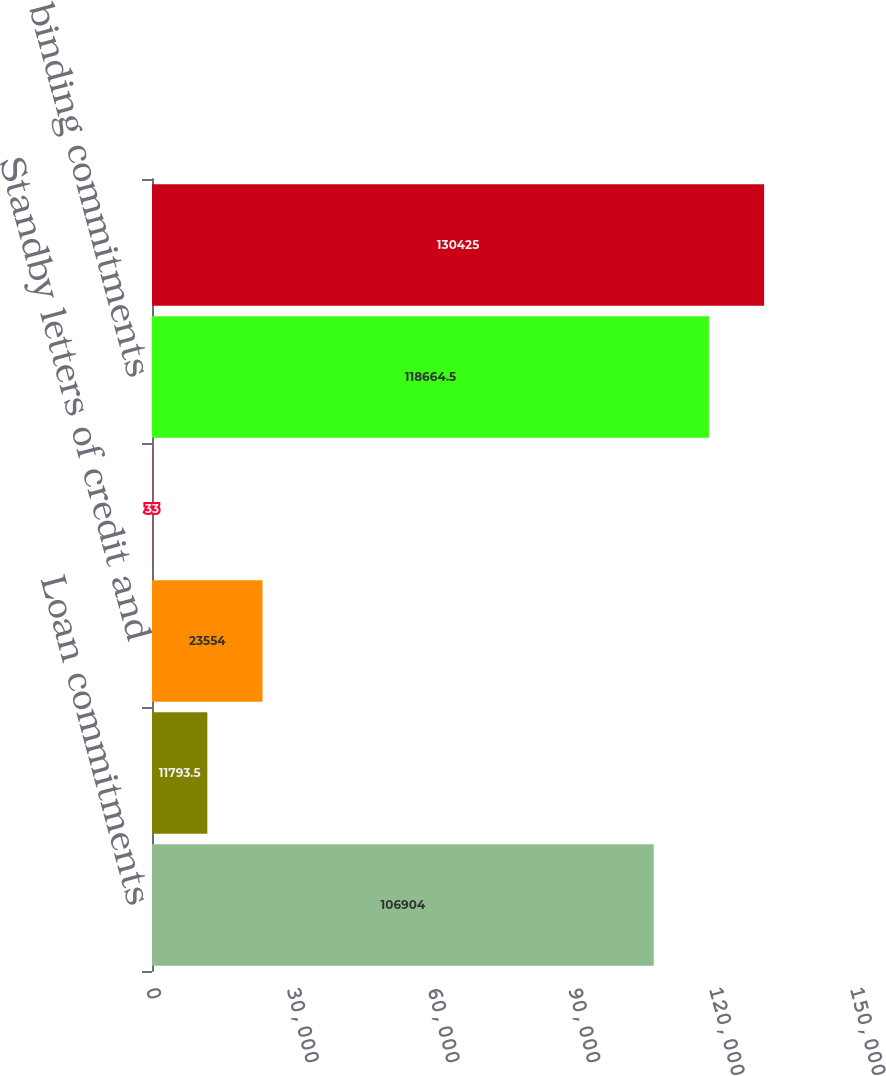<chart> <loc_0><loc_0><loc_500><loc_500><bar_chart><fcel>Loan commitments<fcel>Home equity lines of credit<fcel>Standby letters of credit and<fcel>Commercial letters of credit<fcel>Legally binding commitments<fcel>Total credit extension<nl><fcel>106904<fcel>11793.5<fcel>23554<fcel>33<fcel>118664<fcel>130425<nl></chart> 